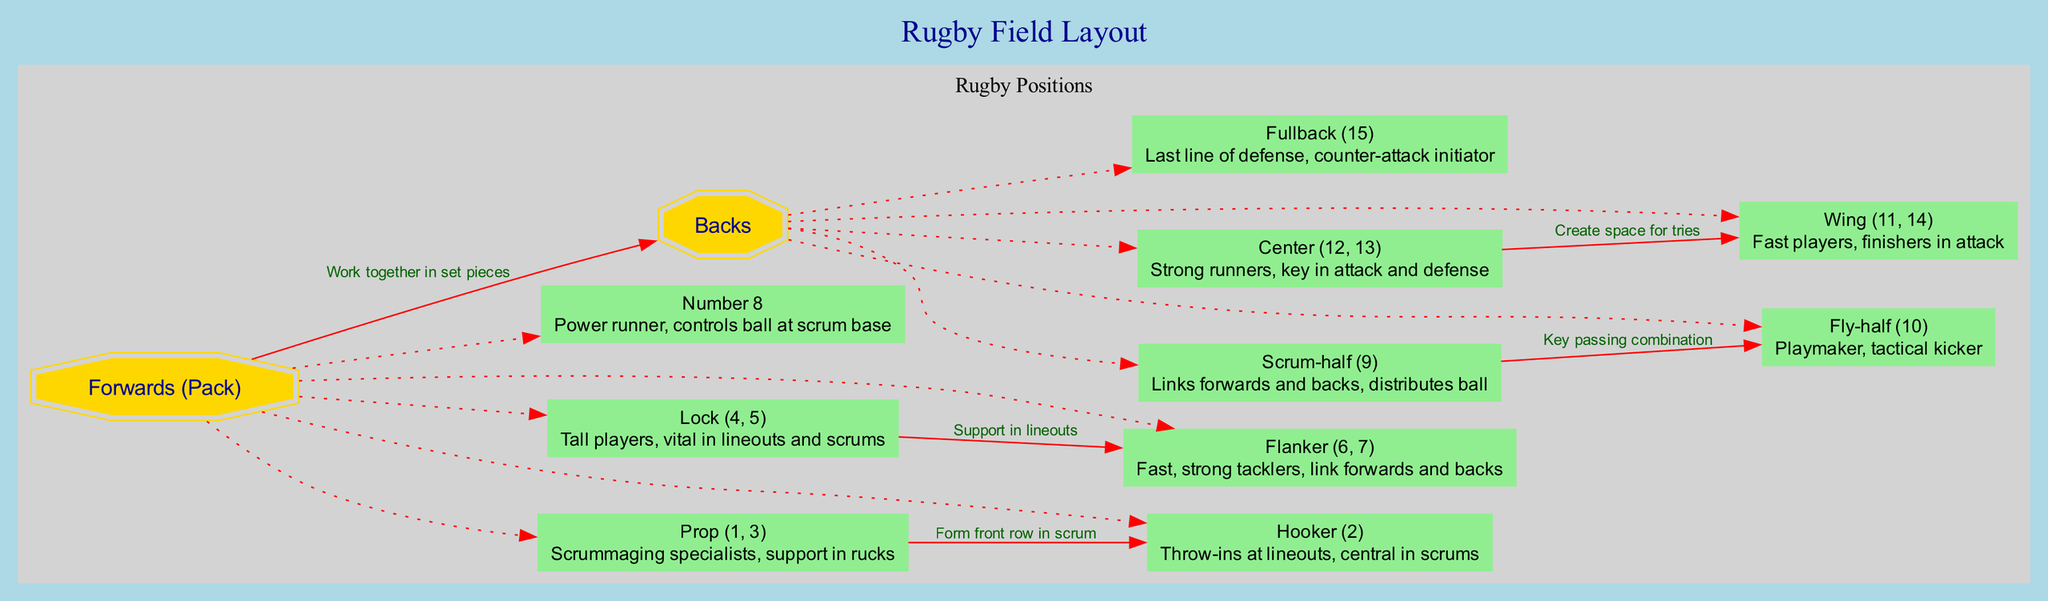What are the two main groups of players on a rugby team? The diagram clearly outlines two primary categories of players: "Forwards (Pack)" and "Backs." These categories are visually connected to emphasize their importance in the game.
Answer: Forwards (Pack) and Backs What role does the hooker play? The diagram indicates that the hooker is responsible for throw-ins at lineouts and is central in scrums, as described in the node related to this position.
Answer: Throw-ins at lineouts, central in scrums How many flankers are there in a rugby team? According to the diagram, the flanker position is listed as (6, 7), indicating that there are two flankers on a rugby team.
Answer: 2 Which players work together in a key passing combination? The diagram specifies that the Scrum-half and Fly-half are involved in a key passing combination, highlighting their interlinked roles in attacking play.
Answer: Scrum-half and Fly-half What is the primary role of centers in rugby? The position of center is described in the diagram as strong runners who play a key role in attack and defense, emphasizing their importance in both aspects of the game.
Answer: Strong runners, key in attack and defense Which two player positions form the front row in a scrum? The diagram explicitly states that the Prop and Hooker combine to form the front row in scrum scenarios, indicating their joint role in this crucial aspect of play.
Answer: Prop and Hooker What is the responsibility of the fullback on the rugby field? The diagram indicates that the fullback serves as the last line of defense and is responsible for initiating counter-attacks, summarizing their critical role in both defensive and offensive play.
Answer: Last line of defense, counter-attack initiator What component connects centers and wings? The diagram illustrates that centers create space for wings to score tries, indicating the collaborative nature of their positions in offensive strategies.
Answer: Create space for tries How many players are traditionally classified as locks? The diagram identifies locks as positions 4 and 5, indicating there are typically two players classified in this role on the team.
Answer: 2 